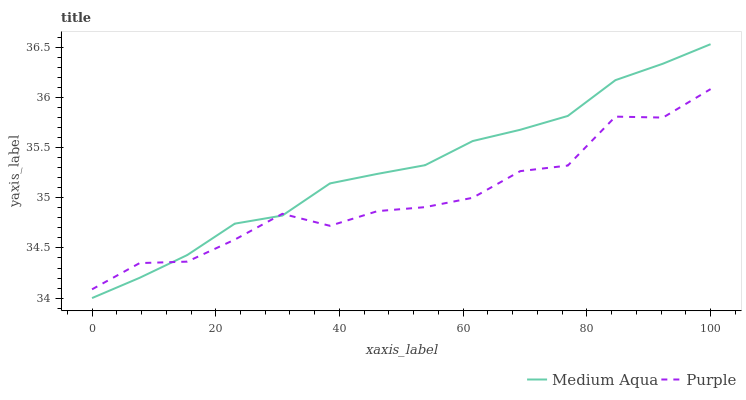Does Purple have the minimum area under the curve?
Answer yes or no. Yes. Does Medium Aqua have the maximum area under the curve?
Answer yes or no. Yes. Does Medium Aqua have the minimum area under the curve?
Answer yes or no. No. Is Medium Aqua the smoothest?
Answer yes or no. Yes. Is Purple the roughest?
Answer yes or no. Yes. Is Medium Aqua the roughest?
Answer yes or no. No. Does Medium Aqua have the lowest value?
Answer yes or no. Yes. Does Medium Aqua have the highest value?
Answer yes or no. Yes. Does Purple intersect Medium Aqua?
Answer yes or no. Yes. Is Purple less than Medium Aqua?
Answer yes or no. No. Is Purple greater than Medium Aqua?
Answer yes or no. No. 